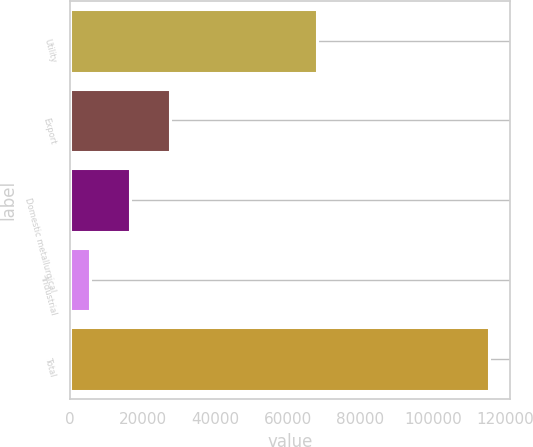Convert chart to OTSL. <chart><loc_0><loc_0><loc_500><loc_500><bar_chart><fcel>Utility<fcel>Export<fcel>Domestic metallurgical<fcel>Industrial<fcel>Total<nl><fcel>67899<fcel>27551.8<fcel>16548.4<fcel>5545<fcel>115579<nl></chart> 